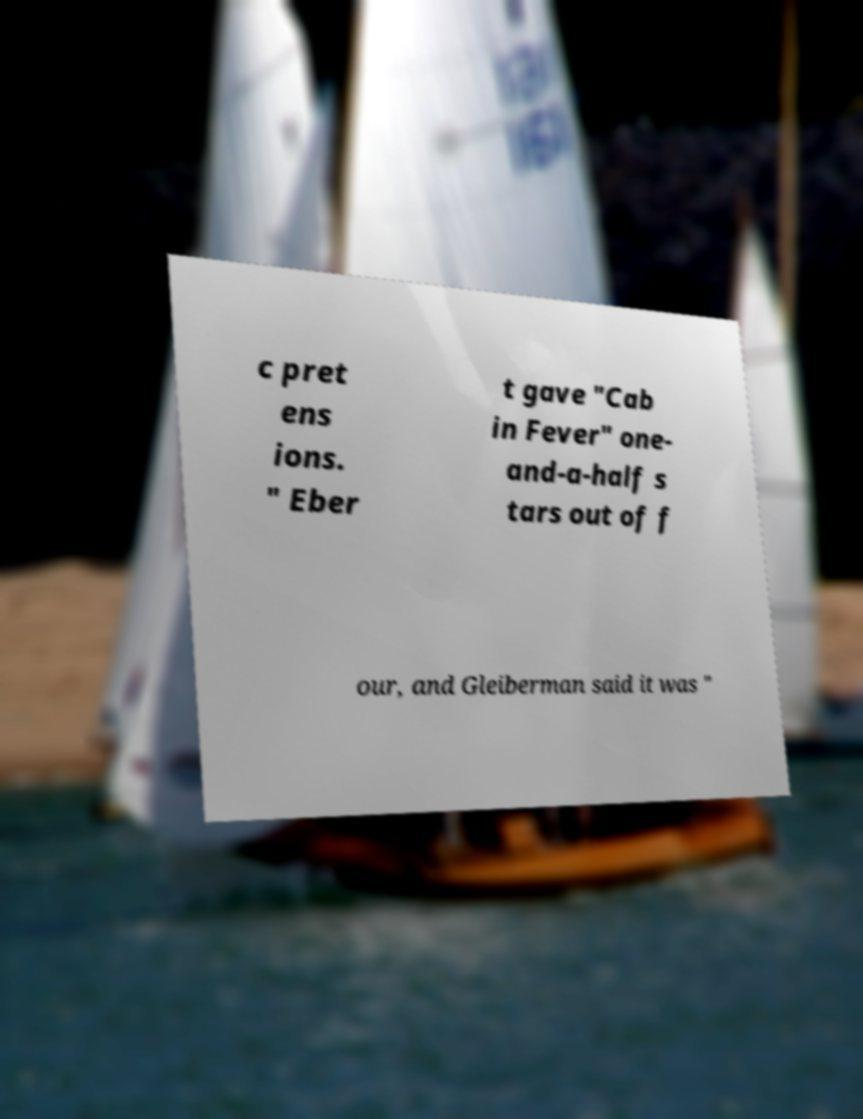What messages or text are displayed in this image? I need them in a readable, typed format. c pret ens ions. " Eber t gave "Cab in Fever" one- and-a-half s tars out of f our, and Gleiberman said it was " 